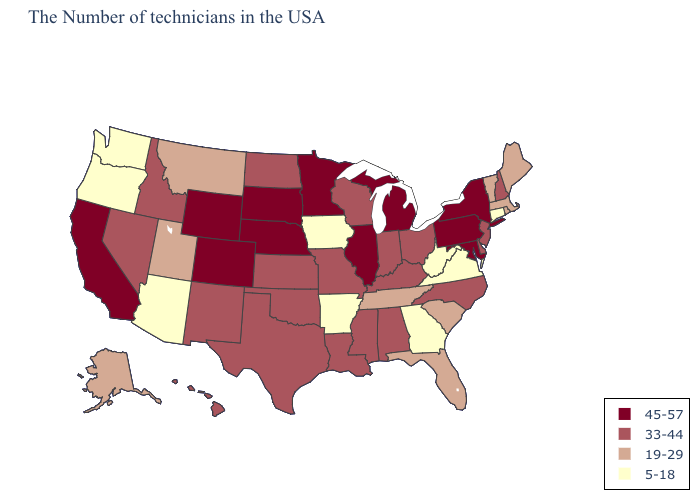Among the states that border Vermont , does New Hampshire have the lowest value?
Answer briefly. No. Among the states that border Arizona , does Utah have the highest value?
Write a very short answer. No. Name the states that have a value in the range 33-44?
Short answer required. New Hampshire, New Jersey, Delaware, North Carolina, Ohio, Kentucky, Indiana, Alabama, Wisconsin, Mississippi, Louisiana, Missouri, Kansas, Oklahoma, Texas, North Dakota, New Mexico, Idaho, Nevada, Hawaii. What is the lowest value in states that border South Dakota?
Be succinct. 5-18. Among the states that border Georgia , which have the highest value?
Answer briefly. North Carolina, Alabama. What is the value of Vermont?
Write a very short answer. 19-29. What is the lowest value in the West?
Give a very brief answer. 5-18. Name the states that have a value in the range 45-57?
Short answer required. New York, Maryland, Pennsylvania, Michigan, Illinois, Minnesota, Nebraska, South Dakota, Wyoming, Colorado, California. Name the states that have a value in the range 45-57?
Be succinct. New York, Maryland, Pennsylvania, Michigan, Illinois, Minnesota, Nebraska, South Dakota, Wyoming, Colorado, California. Name the states that have a value in the range 33-44?
Write a very short answer. New Hampshire, New Jersey, Delaware, North Carolina, Ohio, Kentucky, Indiana, Alabama, Wisconsin, Mississippi, Louisiana, Missouri, Kansas, Oklahoma, Texas, North Dakota, New Mexico, Idaho, Nevada, Hawaii. What is the value of Oregon?
Be succinct. 5-18. Name the states that have a value in the range 19-29?
Concise answer only. Maine, Massachusetts, Rhode Island, Vermont, South Carolina, Florida, Tennessee, Utah, Montana, Alaska. Does West Virginia have a higher value than Colorado?
Be succinct. No. Does Rhode Island have a higher value than Massachusetts?
Answer briefly. No. Name the states that have a value in the range 33-44?
Short answer required. New Hampshire, New Jersey, Delaware, North Carolina, Ohio, Kentucky, Indiana, Alabama, Wisconsin, Mississippi, Louisiana, Missouri, Kansas, Oklahoma, Texas, North Dakota, New Mexico, Idaho, Nevada, Hawaii. 